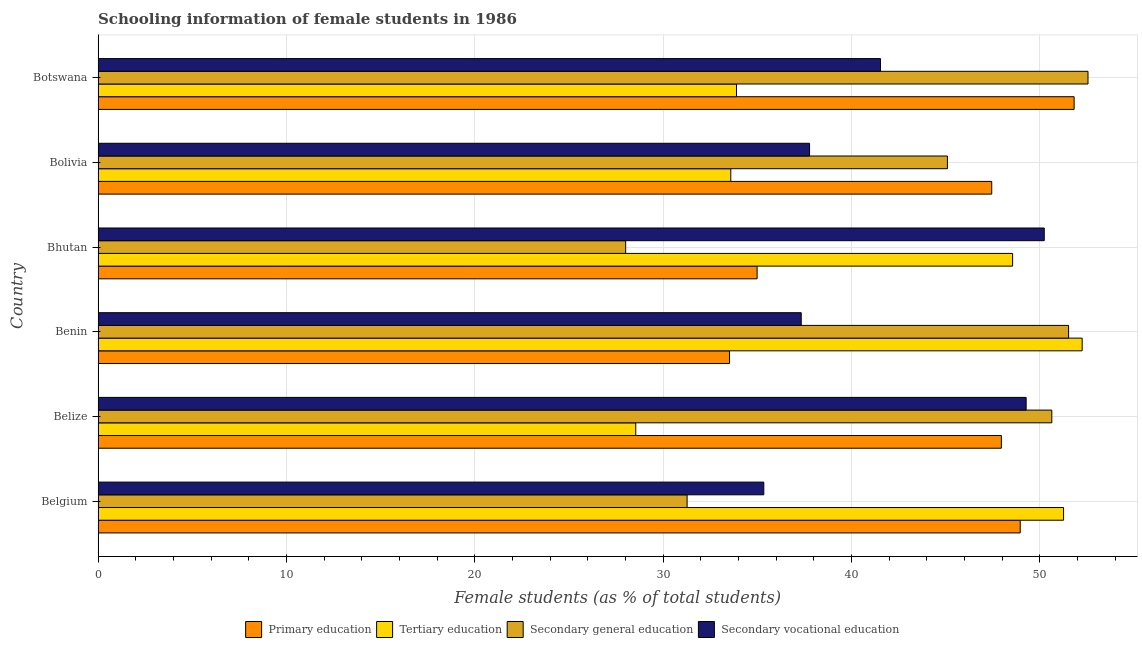How many bars are there on the 6th tick from the bottom?
Make the answer very short. 4. What is the label of the 3rd group of bars from the top?
Give a very brief answer. Bhutan. What is the percentage of female students in secondary education in Bolivia?
Give a very brief answer. 45.09. Across all countries, what is the maximum percentage of female students in tertiary education?
Your response must be concise. 52.24. Across all countries, what is the minimum percentage of female students in secondary education?
Ensure brevity in your answer.  28.01. In which country was the percentage of female students in primary education maximum?
Your response must be concise. Botswana. In which country was the percentage of female students in secondary education minimum?
Ensure brevity in your answer.  Bhutan. What is the total percentage of female students in secondary education in the graph?
Provide a short and direct response. 259.06. What is the difference between the percentage of female students in secondary education in Bhutan and that in Botswana?
Give a very brief answer. -24.54. What is the difference between the percentage of female students in tertiary education in Benin and the percentage of female students in secondary education in Bhutan?
Provide a short and direct response. 24.23. What is the average percentage of female students in secondary vocational education per country?
Offer a terse response. 41.91. What is the difference between the percentage of female students in primary education and percentage of female students in tertiary education in Bolivia?
Make the answer very short. 13.85. In how many countries, is the percentage of female students in primary education greater than 34 %?
Your answer should be very brief. 5. What is the ratio of the percentage of female students in tertiary education in Bolivia to that in Botswana?
Offer a terse response. 0.99. Is the difference between the percentage of female students in secondary education in Belize and Bolivia greater than the difference between the percentage of female students in secondary vocational education in Belize and Bolivia?
Your answer should be very brief. No. What is the difference between the highest and the second highest percentage of female students in primary education?
Your answer should be very brief. 2.86. What is the difference between the highest and the lowest percentage of female students in secondary education?
Provide a short and direct response. 24.54. Is it the case that in every country, the sum of the percentage of female students in tertiary education and percentage of female students in secondary vocational education is greater than the sum of percentage of female students in primary education and percentage of female students in secondary education?
Keep it short and to the point. No. What does the 3rd bar from the top in Bhutan represents?
Offer a terse response. Tertiary education. Is it the case that in every country, the sum of the percentage of female students in primary education and percentage of female students in tertiary education is greater than the percentage of female students in secondary education?
Ensure brevity in your answer.  Yes. How many bars are there?
Keep it short and to the point. 24. Are all the bars in the graph horizontal?
Offer a very short reply. Yes. What is the difference between two consecutive major ticks on the X-axis?
Offer a very short reply. 10. Does the graph contain any zero values?
Make the answer very short. No. Where does the legend appear in the graph?
Give a very brief answer. Bottom center. How many legend labels are there?
Your response must be concise. 4. How are the legend labels stacked?
Give a very brief answer. Horizontal. What is the title of the graph?
Make the answer very short. Schooling information of female students in 1986. What is the label or title of the X-axis?
Keep it short and to the point. Female students (as % of total students). What is the Female students (as % of total students) in Primary education in Belgium?
Provide a succinct answer. 48.95. What is the Female students (as % of total students) in Tertiary education in Belgium?
Make the answer very short. 51.25. What is the Female students (as % of total students) in Secondary general education in Belgium?
Your answer should be compact. 31.27. What is the Female students (as % of total students) of Secondary vocational education in Belgium?
Make the answer very short. 35.34. What is the Female students (as % of total students) of Primary education in Belize?
Your answer should be very brief. 47.95. What is the Female students (as % of total students) of Tertiary education in Belize?
Keep it short and to the point. 28.54. What is the Female students (as % of total students) of Secondary general education in Belize?
Your response must be concise. 50.63. What is the Female students (as % of total students) in Secondary vocational education in Belize?
Your answer should be compact. 49.27. What is the Female students (as % of total students) of Primary education in Benin?
Provide a short and direct response. 33.52. What is the Female students (as % of total students) of Tertiary education in Benin?
Give a very brief answer. 52.24. What is the Female students (as % of total students) of Secondary general education in Benin?
Your response must be concise. 51.52. What is the Female students (as % of total students) in Secondary vocational education in Benin?
Provide a short and direct response. 37.33. What is the Female students (as % of total students) in Primary education in Bhutan?
Ensure brevity in your answer.  34.98. What is the Female students (as % of total students) of Tertiary education in Bhutan?
Your answer should be compact. 48.55. What is the Female students (as % of total students) of Secondary general education in Bhutan?
Ensure brevity in your answer.  28.01. What is the Female students (as % of total students) in Secondary vocational education in Bhutan?
Keep it short and to the point. 50.23. What is the Female students (as % of total students) in Primary education in Bolivia?
Ensure brevity in your answer.  47.44. What is the Female students (as % of total students) in Tertiary education in Bolivia?
Provide a succinct answer. 33.59. What is the Female students (as % of total students) of Secondary general education in Bolivia?
Your answer should be very brief. 45.09. What is the Female students (as % of total students) of Secondary vocational education in Bolivia?
Your answer should be very brief. 37.77. What is the Female students (as % of total students) of Primary education in Botswana?
Your answer should be compact. 51.81. What is the Female students (as % of total students) of Tertiary education in Botswana?
Offer a very short reply. 33.89. What is the Female students (as % of total students) of Secondary general education in Botswana?
Provide a short and direct response. 52.55. What is the Female students (as % of total students) of Secondary vocational education in Botswana?
Make the answer very short. 41.53. Across all countries, what is the maximum Female students (as % of total students) in Primary education?
Your response must be concise. 51.81. Across all countries, what is the maximum Female students (as % of total students) in Tertiary education?
Provide a succinct answer. 52.24. Across all countries, what is the maximum Female students (as % of total students) of Secondary general education?
Your response must be concise. 52.55. Across all countries, what is the maximum Female students (as % of total students) in Secondary vocational education?
Ensure brevity in your answer.  50.23. Across all countries, what is the minimum Female students (as % of total students) in Primary education?
Your response must be concise. 33.52. Across all countries, what is the minimum Female students (as % of total students) of Tertiary education?
Provide a succinct answer. 28.54. Across all countries, what is the minimum Female students (as % of total students) in Secondary general education?
Keep it short and to the point. 28.01. Across all countries, what is the minimum Female students (as % of total students) of Secondary vocational education?
Keep it short and to the point. 35.34. What is the total Female students (as % of total students) of Primary education in the graph?
Offer a very short reply. 264.66. What is the total Female students (as % of total students) of Tertiary education in the graph?
Give a very brief answer. 248.06. What is the total Female students (as % of total students) of Secondary general education in the graph?
Provide a succinct answer. 259.06. What is the total Female students (as % of total students) in Secondary vocational education in the graph?
Offer a terse response. 251.46. What is the difference between the Female students (as % of total students) of Tertiary education in Belgium and that in Belize?
Your answer should be very brief. 22.71. What is the difference between the Female students (as % of total students) in Secondary general education in Belgium and that in Belize?
Offer a very short reply. -19.36. What is the difference between the Female students (as % of total students) of Secondary vocational education in Belgium and that in Belize?
Provide a short and direct response. -13.93. What is the difference between the Female students (as % of total students) in Primary education in Belgium and that in Benin?
Your response must be concise. 15.43. What is the difference between the Female students (as % of total students) of Tertiary education in Belgium and that in Benin?
Offer a very short reply. -0.99. What is the difference between the Female students (as % of total students) in Secondary general education in Belgium and that in Benin?
Offer a terse response. -20.25. What is the difference between the Female students (as % of total students) of Secondary vocational education in Belgium and that in Benin?
Offer a very short reply. -1.99. What is the difference between the Female students (as % of total students) in Primary education in Belgium and that in Bhutan?
Ensure brevity in your answer.  13.97. What is the difference between the Female students (as % of total students) of Tertiary education in Belgium and that in Bhutan?
Ensure brevity in your answer.  2.7. What is the difference between the Female students (as % of total students) in Secondary general education in Belgium and that in Bhutan?
Offer a terse response. 3.26. What is the difference between the Female students (as % of total students) in Secondary vocational education in Belgium and that in Bhutan?
Ensure brevity in your answer.  -14.89. What is the difference between the Female students (as % of total students) of Primary education in Belgium and that in Bolivia?
Offer a terse response. 1.51. What is the difference between the Female students (as % of total students) in Tertiary education in Belgium and that in Bolivia?
Ensure brevity in your answer.  17.67. What is the difference between the Female students (as % of total students) of Secondary general education in Belgium and that in Bolivia?
Keep it short and to the point. -13.82. What is the difference between the Female students (as % of total students) of Secondary vocational education in Belgium and that in Bolivia?
Your response must be concise. -2.43. What is the difference between the Female students (as % of total students) in Primary education in Belgium and that in Botswana?
Offer a very short reply. -2.86. What is the difference between the Female students (as % of total students) in Tertiary education in Belgium and that in Botswana?
Offer a very short reply. 17.36. What is the difference between the Female students (as % of total students) in Secondary general education in Belgium and that in Botswana?
Offer a very short reply. -21.28. What is the difference between the Female students (as % of total students) of Secondary vocational education in Belgium and that in Botswana?
Provide a succinct answer. -6.19. What is the difference between the Female students (as % of total students) in Primary education in Belize and that in Benin?
Your answer should be very brief. 14.43. What is the difference between the Female students (as % of total students) of Tertiary education in Belize and that in Benin?
Keep it short and to the point. -23.7. What is the difference between the Female students (as % of total students) in Secondary general education in Belize and that in Benin?
Offer a terse response. -0.89. What is the difference between the Female students (as % of total students) in Secondary vocational education in Belize and that in Benin?
Give a very brief answer. 11.94. What is the difference between the Female students (as % of total students) in Primary education in Belize and that in Bhutan?
Ensure brevity in your answer.  12.97. What is the difference between the Female students (as % of total students) of Tertiary education in Belize and that in Bhutan?
Your response must be concise. -20.01. What is the difference between the Female students (as % of total students) of Secondary general education in Belize and that in Bhutan?
Ensure brevity in your answer.  22.62. What is the difference between the Female students (as % of total students) in Secondary vocational education in Belize and that in Bhutan?
Your answer should be very brief. -0.96. What is the difference between the Female students (as % of total students) in Primary education in Belize and that in Bolivia?
Make the answer very short. 0.51. What is the difference between the Female students (as % of total students) in Tertiary education in Belize and that in Bolivia?
Your response must be concise. -5.04. What is the difference between the Female students (as % of total students) of Secondary general education in Belize and that in Bolivia?
Make the answer very short. 5.54. What is the difference between the Female students (as % of total students) in Secondary vocational education in Belize and that in Bolivia?
Your answer should be compact. 11.5. What is the difference between the Female students (as % of total students) of Primary education in Belize and that in Botswana?
Offer a terse response. -3.86. What is the difference between the Female students (as % of total students) of Tertiary education in Belize and that in Botswana?
Provide a succinct answer. -5.35. What is the difference between the Female students (as % of total students) of Secondary general education in Belize and that in Botswana?
Make the answer very short. -1.92. What is the difference between the Female students (as % of total students) of Secondary vocational education in Belize and that in Botswana?
Give a very brief answer. 7.73. What is the difference between the Female students (as % of total students) of Primary education in Benin and that in Bhutan?
Ensure brevity in your answer.  -1.46. What is the difference between the Female students (as % of total students) in Tertiary education in Benin and that in Bhutan?
Your answer should be compact. 3.69. What is the difference between the Female students (as % of total students) of Secondary general education in Benin and that in Bhutan?
Your response must be concise. 23.51. What is the difference between the Female students (as % of total students) in Secondary vocational education in Benin and that in Bhutan?
Ensure brevity in your answer.  -12.9. What is the difference between the Female students (as % of total students) of Primary education in Benin and that in Bolivia?
Your response must be concise. -13.92. What is the difference between the Female students (as % of total students) in Tertiary education in Benin and that in Bolivia?
Offer a very short reply. 18.65. What is the difference between the Female students (as % of total students) of Secondary general education in Benin and that in Bolivia?
Keep it short and to the point. 6.43. What is the difference between the Female students (as % of total students) of Secondary vocational education in Benin and that in Bolivia?
Ensure brevity in your answer.  -0.44. What is the difference between the Female students (as % of total students) of Primary education in Benin and that in Botswana?
Provide a short and direct response. -18.29. What is the difference between the Female students (as % of total students) of Tertiary education in Benin and that in Botswana?
Offer a terse response. 18.35. What is the difference between the Female students (as % of total students) of Secondary general education in Benin and that in Botswana?
Keep it short and to the point. -1.03. What is the difference between the Female students (as % of total students) in Secondary vocational education in Benin and that in Botswana?
Ensure brevity in your answer.  -4.21. What is the difference between the Female students (as % of total students) in Primary education in Bhutan and that in Bolivia?
Your answer should be compact. -12.46. What is the difference between the Female students (as % of total students) in Tertiary education in Bhutan and that in Bolivia?
Your answer should be compact. 14.96. What is the difference between the Female students (as % of total students) in Secondary general education in Bhutan and that in Bolivia?
Your answer should be very brief. -17.08. What is the difference between the Female students (as % of total students) in Secondary vocational education in Bhutan and that in Bolivia?
Provide a succinct answer. 12.46. What is the difference between the Female students (as % of total students) of Primary education in Bhutan and that in Botswana?
Your answer should be very brief. -16.83. What is the difference between the Female students (as % of total students) in Tertiary education in Bhutan and that in Botswana?
Keep it short and to the point. 14.66. What is the difference between the Female students (as % of total students) in Secondary general education in Bhutan and that in Botswana?
Provide a succinct answer. -24.54. What is the difference between the Female students (as % of total students) of Secondary vocational education in Bhutan and that in Botswana?
Offer a very short reply. 8.69. What is the difference between the Female students (as % of total students) in Primary education in Bolivia and that in Botswana?
Your response must be concise. -4.37. What is the difference between the Female students (as % of total students) of Tertiary education in Bolivia and that in Botswana?
Ensure brevity in your answer.  -0.3. What is the difference between the Female students (as % of total students) in Secondary general education in Bolivia and that in Botswana?
Your answer should be very brief. -7.46. What is the difference between the Female students (as % of total students) in Secondary vocational education in Bolivia and that in Botswana?
Your response must be concise. -3.76. What is the difference between the Female students (as % of total students) of Primary education in Belgium and the Female students (as % of total students) of Tertiary education in Belize?
Make the answer very short. 20.41. What is the difference between the Female students (as % of total students) of Primary education in Belgium and the Female students (as % of total students) of Secondary general education in Belize?
Provide a succinct answer. -1.68. What is the difference between the Female students (as % of total students) in Primary education in Belgium and the Female students (as % of total students) in Secondary vocational education in Belize?
Offer a very short reply. -0.31. What is the difference between the Female students (as % of total students) of Tertiary education in Belgium and the Female students (as % of total students) of Secondary general education in Belize?
Give a very brief answer. 0.62. What is the difference between the Female students (as % of total students) in Tertiary education in Belgium and the Female students (as % of total students) in Secondary vocational education in Belize?
Give a very brief answer. 1.99. What is the difference between the Female students (as % of total students) in Secondary general education in Belgium and the Female students (as % of total students) in Secondary vocational education in Belize?
Offer a very short reply. -18. What is the difference between the Female students (as % of total students) of Primary education in Belgium and the Female students (as % of total students) of Tertiary education in Benin?
Provide a short and direct response. -3.29. What is the difference between the Female students (as % of total students) in Primary education in Belgium and the Female students (as % of total students) in Secondary general education in Benin?
Ensure brevity in your answer.  -2.57. What is the difference between the Female students (as % of total students) of Primary education in Belgium and the Female students (as % of total students) of Secondary vocational education in Benin?
Keep it short and to the point. 11.62. What is the difference between the Female students (as % of total students) of Tertiary education in Belgium and the Female students (as % of total students) of Secondary general education in Benin?
Ensure brevity in your answer.  -0.27. What is the difference between the Female students (as % of total students) in Tertiary education in Belgium and the Female students (as % of total students) in Secondary vocational education in Benin?
Keep it short and to the point. 13.93. What is the difference between the Female students (as % of total students) of Secondary general education in Belgium and the Female students (as % of total students) of Secondary vocational education in Benin?
Your response must be concise. -6.06. What is the difference between the Female students (as % of total students) of Primary education in Belgium and the Female students (as % of total students) of Tertiary education in Bhutan?
Give a very brief answer. 0.4. What is the difference between the Female students (as % of total students) of Primary education in Belgium and the Female students (as % of total students) of Secondary general education in Bhutan?
Your answer should be compact. 20.94. What is the difference between the Female students (as % of total students) of Primary education in Belgium and the Female students (as % of total students) of Secondary vocational education in Bhutan?
Provide a short and direct response. -1.28. What is the difference between the Female students (as % of total students) of Tertiary education in Belgium and the Female students (as % of total students) of Secondary general education in Bhutan?
Offer a very short reply. 23.25. What is the difference between the Female students (as % of total students) of Tertiary education in Belgium and the Female students (as % of total students) of Secondary vocational education in Bhutan?
Offer a terse response. 1.03. What is the difference between the Female students (as % of total students) of Secondary general education in Belgium and the Female students (as % of total students) of Secondary vocational education in Bhutan?
Offer a very short reply. -18.96. What is the difference between the Female students (as % of total students) of Primary education in Belgium and the Female students (as % of total students) of Tertiary education in Bolivia?
Make the answer very short. 15.36. What is the difference between the Female students (as % of total students) of Primary education in Belgium and the Female students (as % of total students) of Secondary general education in Bolivia?
Ensure brevity in your answer.  3.86. What is the difference between the Female students (as % of total students) in Primary education in Belgium and the Female students (as % of total students) in Secondary vocational education in Bolivia?
Provide a short and direct response. 11.18. What is the difference between the Female students (as % of total students) in Tertiary education in Belgium and the Female students (as % of total students) in Secondary general education in Bolivia?
Provide a succinct answer. 6.17. What is the difference between the Female students (as % of total students) in Tertiary education in Belgium and the Female students (as % of total students) in Secondary vocational education in Bolivia?
Keep it short and to the point. 13.48. What is the difference between the Female students (as % of total students) in Secondary general education in Belgium and the Female students (as % of total students) in Secondary vocational education in Bolivia?
Give a very brief answer. -6.5. What is the difference between the Female students (as % of total students) of Primary education in Belgium and the Female students (as % of total students) of Tertiary education in Botswana?
Ensure brevity in your answer.  15.06. What is the difference between the Female students (as % of total students) of Primary education in Belgium and the Female students (as % of total students) of Secondary general education in Botswana?
Your answer should be compact. -3.6. What is the difference between the Female students (as % of total students) of Primary education in Belgium and the Female students (as % of total students) of Secondary vocational education in Botswana?
Provide a short and direct response. 7.42. What is the difference between the Female students (as % of total students) in Tertiary education in Belgium and the Female students (as % of total students) in Secondary general education in Botswana?
Keep it short and to the point. -1.3. What is the difference between the Female students (as % of total students) in Tertiary education in Belgium and the Female students (as % of total students) in Secondary vocational education in Botswana?
Provide a succinct answer. 9.72. What is the difference between the Female students (as % of total students) in Secondary general education in Belgium and the Female students (as % of total students) in Secondary vocational education in Botswana?
Offer a very short reply. -10.26. What is the difference between the Female students (as % of total students) of Primary education in Belize and the Female students (as % of total students) of Tertiary education in Benin?
Keep it short and to the point. -4.29. What is the difference between the Female students (as % of total students) of Primary education in Belize and the Female students (as % of total students) of Secondary general education in Benin?
Your answer should be very brief. -3.57. What is the difference between the Female students (as % of total students) in Primary education in Belize and the Female students (as % of total students) in Secondary vocational education in Benin?
Keep it short and to the point. 10.62. What is the difference between the Female students (as % of total students) of Tertiary education in Belize and the Female students (as % of total students) of Secondary general education in Benin?
Give a very brief answer. -22.98. What is the difference between the Female students (as % of total students) of Tertiary education in Belize and the Female students (as % of total students) of Secondary vocational education in Benin?
Offer a terse response. -8.78. What is the difference between the Female students (as % of total students) of Secondary general education in Belize and the Female students (as % of total students) of Secondary vocational education in Benin?
Your answer should be very brief. 13.3. What is the difference between the Female students (as % of total students) in Primary education in Belize and the Female students (as % of total students) in Tertiary education in Bhutan?
Your answer should be compact. -0.6. What is the difference between the Female students (as % of total students) of Primary education in Belize and the Female students (as % of total students) of Secondary general education in Bhutan?
Your answer should be compact. 19.94. What is the difference between the Female students (as % of total students) of Primary education in Belize and the Female students (as % of total students) of Secondary vocational education in Bhutan?
Provide a succinct answer. -2.28. What is the difference between the Female students (as % of total students) of Tertiary education in Belize and the Female students (as % of total students) of Secondary general education in Bhutan?
Your answer should be compact. 0.54. What is the difference between the Female students (as % of total students) of Tertiary education in Belize and the Female students (as % of total students) of Secondary vocational education in Bhutan?
Ensure brevity in your answer.  -21.68. What is the difference between the Female students (as % of total students) of Secondary general education in Belize and the Female students (as % of total students) of Secondary vocational education in Bhutan?
Your answer should be compact. 0.4. What is the difference between the Female students (as % of total students) of Primary education in Belize and the Female students (as % of total students) of Tertiary education in Bolivia?
Your response must be concise. 14.36. What is the difference between the Female students (as % of total students) of Primary education in Belize and the Female students (as % of total students) of Secondary general education in Bolivia?
Provide a succinct answer. 2.86. What is the difference between the Female students (as % of total students) in Primary education in Belize and the Female students (as % of total students) in Secondary vocational education in Bolivia?
Offer a terse response. 10.18. What is the difference between the Female students (as % of total students) of Tertiary education in Belize and the Female students (as % of total students) of Secondary general education in Bolivia?
Your answer should be compact. -16.54. What is the difference between the Female students (as % of total students) in Tertiary education in Belize and the Female students (as % of total students) in Secondary vocational education in Bolivia?
Make the answer very short. -9.23. What is the difference between the Female students (as % of total students) of Secondary general education in Belize and the Female students (as % of total students) of Secondary vocational education in Bolivia?
Your answer should be compact. 12.86. What is the difference between the Female students (as % of total students) in Primary education in Belize and the Female students (as % of total students) in Tertiary education in Botswana?
Your response must be concise. 14.06. What is the difference between the Female students (as % of total students) of Primary education in Belize and the Female students (as % of total students) of Secondary general education in Botswana?
Make the answer very short. -4.6. What is the difference between the Female students (as % of total students) in Primary education in Belize and the Female students (as % of total students) in Secondary vocational education in Botswana?
Ensure brevity in your answer.  6.42. What is the difference between the Female students (as % of total students) of Tertiary education in Belize and the Female students (as % of total students) of Secondary general education in Botswana?
Make the answer very short. -24.01. What is the difference between the Female students (as % of total students) of Tertiary education in Belize and the Female students (as % of total students) of Secondary vocational education in Botswana?
Your answer should be very brief. -12.99. What is the difference between the Female students (as % of total students) in Secondary general education in Belize and the Female students (as % of total students) in Secondary vocational education in Botswana?
Your answer should be compact. 9.1. What is the difference between the Female students (as % of total students) of Primary education in Benin and the Female students (as % of total students) of Tertiary education in Bhutan?
Ensure brevity in your answer.  -15.03. What is the difference between the Female students (as % of total students) of Primary education in Benin and the Female students (as % of total students) of Secondary general education in Bhutan?
Your answer should be very brief. 5.51. What is the difference between the Female students (as % of total students) in Primary education in Benin and the Female students (as % of total students) in Secondary vocational education in Bhutan?
Provide a succinct answer. -16.71. What is the difference between the Female students (as % of total students) in Tertiary education in Benin and the Female students (as % of total students) in Secondary general education in Bhutan?
Provide a short and direct response. 24.23. What is the difference between the Female students (as % of total students) of Tertiary education in Benin and the Female students (as % of total students) of Secondary vocational education in Bhutan?
Offer a very short reply. 2.01. What is the difference between the Female students (as % of total students) of Secondary general education in Benin and the Female students (as % of total students) of Secondary vocational education in Bhutan?
Your answer should be very brief. 1.29. What is the difference between the Female students (as % of total students) in Primary education in Benin and the Female students (as % of total students) in Tertiary education in Bolivia?
Make the answer very short. -0.07. What is the difference between the Female students (as % of total students) in Primary education in Benin and the Female students (as % of total students) in Secondary general education in Bolivia?
Your answer should be compact. -11.57. What is the difference between the Female students (as % of total students) of Primary education in Benin and the Female students (as % of total students) of Secondary vocational education in Bolivia?
Offer a terse response. -4.25. What is the difference between the Female students (as % of total students) of Tertiary education in Benin and the Female students (as % of total students) of Secondary general education in Bolivia?
Your answer should be compact. 7.15. What is the difference between the Female students (as % of total students) of Tertiary education in Benin and the Female students (as % of total students) of Secondary vocational education in Bolivia?
Offer a very short reply. 14.47. What is the difference between the Female students (as % of total students) in Secondary general education in Benin and the Female students (as % of total students) in Secondary vocational education in Bolivia?
Ensure brevity in your answer.  13.75. What is the difference between the Female students (as % of total students) of Primary education in Benin and the Female students (as % of total students) of Tertiary education in Botswana?
Ensure brevity in your answer.  -0.37. What is the difference between the Female students (as % of total students) in Primary education in Benin and the Female students (as % of total students) in Secondary general education in Botswana?
Give a very brief answer. -19.03. What is the difference between the Female students (as % of total students) in Primary education in Benin and the Female students (as % of total students) in Secondary vocational education in Botswana?
Make the answer very short. -8.01. What is the difference between the Female students (as % of total students) in Tertiary education in Benin and the Female students (as % of total students) in Secondary general education in Botswana?
Provide a succinct answer. -0.31. What is the difference between the Female students (as % of total students) of Tertiary education in Benin and the Female students (as % of total students) of Secondary vocational education in Botswana?
Keep it short and to the point. 10.71. What is the difference between the Female students (as % of total students) of Secondary general education in Benin and the Female students (as % of total students) of Secondary vocational education in Botswana?
Your answer should be compact. 9.99. What is the difference between the Female students (as % of total students) of Primary education in Bhutan and the Female students (as % of total students) of Tertiary education in Bolivia?
Your response must be concise. 1.4. What is the difference between the Female students (as % of total students) of Primary education in Bhutan and the Female students (as % of total students) of Secondary general education in Bolivia?
Provide a succinct answer. -10.1. What is the difference between the Female students (as % of total students) in Primary education in Bhutan and the Female students (as % of total students) in Secondary vocational education in Bolivia?
Give a very brief answer. -2.79. What is the difference between the Female students (as % of total students) of Tertiary education in Bhutan and the Female students (as % of total students) of Secondary general education in Bolivia?
Offer a terse response. 3.46. What is the difference between the Female students (as % of total students) of Tertiary education in Bhutan and the Female students (as % of total students) of Secondary vocational education in Bolivia?
Give a very brief answer. 10.78. What is the difference between the Female students (as % of total students) in Secondary general education in Bhutan and the Female students (as % of total students) in Secondary vocational education in Bolivia?
Your answer should be compact. -9.76. What is the difference between the Female students (as % of total students) of Primary education in Bhutan and the Female students (as % of total students) of Tertiary education in Botswana?
Your answer should be very brief. 1.09. What is the difference between the Female students (as % of total students) in Primary education in Bhutan and the Female students (as % of total students) in Secondary general education in Botswana?
Ensure brevity in your answer.  -17.57. What is the difference between the Female students (as % of total students) in Primary education in Bhutan and the Female students (as % of total students) in Secondary vocational education in Botswana?
Offer a very short reply. -6.55. What is the difference between the Female students (as % of total students) of Tertiary education in Bhutan and the Female students (as % of total students) of Secondary general education in Botswana?
Your answer should be compact. -4. What is the difference between the Female students (as % of total students) in Tertiary education in Bhutan and the Female students (as % of total students) in Secondary vocational education in Botswana?
Your answer should be compact. 7.01. What is the difference between the Female students (as % of total students) of Secondary general education in Bhutan and the Female students (as % of total students) of Secondary vocational education in Botswana?
Offer a very short reply. -13.53. What is the difference between the Female students (as % of total students) in Primary education in Bolivia and the Female students (as % of total students) in Tertiary education in Botswana?
Offer a very short reply. 13.55. What is the difference between the Female students (as % of total students) in Primary education in Bolivia and the Female students (as % of total students) in Secondary general education in Botswana?
Your answer should be compact. -5.11. What is the difference between the Female students (as % of total students) in Primary education in Bolivia and the Female students (as % of total students) in Secondary vocational education in Botswana?
Make the answer very short. 5.91. What is the difference between the Female students (as % of total students) of Tertiary education in Bolivia and the Female students (as % of total students) of Secondary general education in Botswana?
Make the answer very short. -18.96. What is the difference between the Female students (as % of total students) of Tertiary education in Bolivia and the Female students (as % of total students) of Secondary vocational education in Botswana?
Your response must be concise. -7.95. What is the difference between the Female students (as % of total students) in Secondary general education in Bolivia and the Female students (as % of total students) in Secondary vocational education in Botswana?
Keep it short and to the point. 3.55. What is the average Female students (as % of total students) of Primary education per country?
Ensure brevity in your answer.  44.11. What is the average Female students (as % of total students) in Tertiary education per country?
Offer a terse response. 41.34. What is the average Female students (as % of total students) in Secondary general education per country?
Give a very brief answer. 43.18. What is the average Female students (as % of total students) of Secondary vocational education per country?
Provide a succinct answer. 41.91. What is the difference between the Female students (as % of total students) of Primary education and Female students (as % of total students) of Tertiary education in Belgium?
Provide a succinct answer. -2.3. What is the difference between the Female students (as % of total students) in Primary education and Female students (as % of total students) in Secondary general education in Belgium?
Give a very brief answer. 17.68. What is the difference between the Female students (as % of total students) of Primary education and Female students (as % of total students) of Secondary vocational education in Belgium?
Your answer should be very brief. 13.61. What is the difference between the Female students (as % of total students) of Tertiary education and Female students (as % of total students) of Secondary general education in Belgium?
Your answer should be compact. 19.98. What is the difference between the Female students (as % of total students) of Tertiary education and Female students (as % of total students) of Secondary vocational education in Belgium?
Ensure brevity in your answer.  15.91. What is the difference between the Female students (as % of total students) of Secondary general education and Female students (as % of total students) of Secondary vocational education in Belgium?
Your answer should be very brief. -4.07. What is the difference between the Female students (as % of total students) in Primary education and Female students (as % of total students) in Tertiary education in Belize?
Ensure brevity in your answer.  19.41. What is the difference between the Female students (as % of total students) of Primary education and Female students (as % of total students) of Secondary general education in Belize?
Offer a terse response. -2.68. What is the difference between the Female students (as % of total students) in Primary education and Female students (as % of total students) in Secondary vocational education in Belize?
Your response must be concise. -1.32. What is the difference between the Female students (as % of total students) of Tertiary education and Female students (as % of total students) of Secondary general education in Belize?
Make the answer very short. -22.09. What is the difference between the Female students (as % of total students) of Tertiary education and Female students (as % of total students) of Secondary vocational education in Belize?
Your response must be concise. -20.72. What is the difference between the Female students (as % of total students) of Secondary general education and Female students (as % of total students) of Secondary vocational education in Belize?
Offer a terse response. 1.36. What is the difference between the Female students (as % of total students) in Primary education and Female students (as % of total students) in Tertiary education in Benin?
Provide a short and direct response. -18.72. What is the difference between the Female students (as % of total students) of Primary education and Female students (as % of total students) of Secondary general education in Benin?
Provide a succinct answer. -18. What is the difference between the Female students (as % of total students) in Primary education and Female students (as % of total students) in Secondary vocational education in Benin?
Your response must be concise. -3.81. What is the difference between the Female students (as % of total students) in Tertiary education and Female students (as % of total students) in Secondary general education in Benin?
Your response must be concise. 0.72. What is the difference between the Female students (as % of total students) in Tertiary education and Female students (as % of total students) in Secondary vocational education in Benin?
Ensure brevity in your answer.  14.91. What is the difference between the Female students (as % of total students) in Secondary general education and Female students (as % of total students) in Secondary vocational education in Benin?
Keep it short and to the point. 14.19. What is the difference between the Female students (as % of total students) of Primary education and Female students (as % of total students) of Tertiary education in Bhutan?
Your answer should be compact. -13.56. What is the difference between the Female students (as % of total students) in Primary education and Female students (as % of total students) in Secondary general education in Bhutan?
Your answer should be compact. 6.98. What is the difference between the Female students (as % of total students) in Primary education and Female students (as % of total students) in Secondary vocational education in Bhutan?
Your response must be concise. -15.24. What is the difference between the Female students (as % of total students) in Tertiary education and Female students (as % of total students) in Secondary general education in Bhutan?
Offer a very short reply. 20.54. What is the difference between the Female students (as % of total students) of Tertiary education and Female students (as % of total students) of Secondary vocational education in Bhutan?
Keep it short and to the point. -1.68. What is the difference between the Female students (as % of total students) of Secondary general education and Female students (as % of total students) of Secondary vocational education in Bhutan?
Your answer should be very brief. -22.22. What is the difference between the Female students (as % of total students) of Primary education and Female students (as % of total students) of Tertiary education in Bolivia?
Your answer should be very brief. 13.85. What is the difference between the Female students (as % of total students) of Primary education and Female students (as % of total students) of Secondary general education in Bolivia?
Your answer should be very brief. 2.35. What is the difference between the Female students (as % of total students) of Primary education and Female students (as % of total students) of Secondary vocational education in Bolivia?
Your answer should be compact. 9.67. What is the difference between the Female students (as % of total students) of Tertiary education and Female students (as % of total students) of Secondary general education in Bolivia?
Provide a succinct answer. -11.5. What is the difference between the Female students (as % of total students) in Tertiary education and Female students (as % of total students) in Secondary vocational education in Bolivia?
Ensure brevity in your answer.  -4.18. What is the difference between the Female students (as % of total students) in Secondary general education and Female students (as % of total students) in Secondary vocational education in Bolivia?
Your answer should be very brief. 7.32. What is the difference between the Female students (as % of total students) in Primary education and Female students (as % of total students) in Tertiary education in Botswana?
Your answer should be compact. 17.92. What is the difference between the Female students (as % of total students) of Primary education and Female students (as % of total students) of Secondary general education in Botswana?
Offer a terse response. -0.74. What is the difference between the Female students (as % of total students) of Primary education and Female students (as % of total students) of Secondary vocational education in Botswana?
Give a very brief answer. 10.28. What is the difference between the Female students (as % of total students) in Tertiary education and Female students (as % of total students) in Secondary general education in Botswana?
Your answer should be very brief. -18.66. What is the difference between the Female students (as % of total students) of Tertiary education and Female students (as % of total students) of Secondary vocational education in Botswana?
Provide a short and direct response. -7.64. What is the difference between the Female students (as % of total students) of Secondary general education and Female students (as % of total students) of Secondary vocational education in Botswana?
Provide a short and direct response. 11.02. What is the ratio of the Female students (as % of total students) in Primary education in Belgium to that in Belize?
Provide a short and direct response. 1.02. What is the ratio of the Female students (as % of total students) in Tertiary education in Belgium to that in Belize?
Offer a terse response. 1.8. What is the ratio of the Female students (as % of total students) in Secondary general education in Belgium to that in Belize?
Offer a very short reply. 0.62. What is the ratio of the Female students (as % of total students) in Secondary vocational education in Belgium to that in Belize?
Give a very brief answer. 0.72. What is the ratio of the Female students (as % of total students) in Primary education in Belgium to that in Benin?
Offer a very short reply. 1.46. What is the ratio of the Female students (as % of total students) in Tertiary education in Belgium to that in Benin?
Provide a succinct answer. 0.98. What is the ratio of the Female students (as % of total students) in Secondary general education in Belgium to that in Benin?
Ensure brevity in your answer.  0.61. What is the ratio of the Female students (as % of total students) in Secondary vocational education in Belgium to that in Benin?
Your answer should be compact. 0.95. What is the ratio of the Female students (as % of total students) in Primary education in Belgium to that in Bhutan?
Offer a very short reply. 1.4. What is the ratio of the Female students (as % of total students) of Tertiary education in Belgium to that in Bhutan?
Provide a short and direct response. 1.06. What is the ratio of the Female students (as % of total students) in Secondary general education in Belgium to that in Bhutan?
Provide a short and direct response. 1.12. What is the ratio of the Female students (as % of total students) in Secondary vocational education in Belgium to that in Bhutan?
Your answer should be compact. 0.7. What is the ratio of the Female students (as % of total students) of Primary education in Belgium to that in Bolivia?
Make the answer very short. 1.03. What is the ratio of the Female students (as % of total students) in Tertiary education in Belgium to that in Bolivia?
Offer a terse response. 1.53. What is the ratio of the Female students (as % of total students) of Secondary general education in Belgium to that in Bolivia?
Ensure brevity in your answer.  0.69. What is the ratio of the Female students (as % of total students) in Secondary vocational education in Belgium to that in Bolivia?
Give a very brief answer. 0.94. What is the ratio of the Female students (as % of total students) in Primary education in Belgium to that in Botswana?
Ensure brevity in your answer.  0.94. What is the ratio of the Female students (as % of total students) in Tertiary education in Belgium to that in Botswana?
Make the answer very short. 1.51. What is the ratio of the Female students (as % of total students) in Secondary general education in Belgium to that in Botswana?
Your response must be concise. 0.59. What is the ratio of the Female students (as % of total students) in Secondary vocational education in Belgium to that in Botswana?
Provide a succinct answer. 0.85. What is the ratio of the Female students (as % of total students) in Primary education in Belize to that in Benin?
Ensure brevity in your answer.  1.43. What is the ratio of the Female students (as % of total students) in Tertiary education in Belize to that in Benin?
Keep it short and to the point. 0.55. What is the ratio of the Female students (as % of total students) in Secondary general education in Belize to that in Benin?
Provide a short and direct response. 0.98. What is the ratio of the Female students (as % of total students) in Secondary vocational education in Belize to that in Benin?
Your answer should be very brief. 1.32. What is the ratio of the Female students (as % of total students) in Primary education in Belize to that in Bhutan?
Make the answer very short. 1.37. What is the ratio of the Female students (as % of total students) in Tertiary education in Belize to that in Bhutan?
Offer a terse response. 0.59. What is the ratio of the Female students (as % of total students) in Secondary general education in Belize to that in Bhutan?
Offer a terse response. 1.81. What is the ratio of the Female students (as % of total students) of Secondary vocational education in Belize to that in Bhutan?
Provide a succinct answer. 0.98. What is the ratio of the Female students (as % of total students) in Primary education in Belize to that in Bolivia?
Give a very brief answer. 1.01. What is the ratio of the Female students (as % of total students) in Tertiary education in Belize to that in Bolivia?
Your answer should be compact. 0.85. What is the ratio of the Female students (as % of total students) in Secondary general education in Belize to that in Bolivia?
Make the answer very short. 1.12. What is the ratio of the Female students (as % of total students) in Secondary vocational education in Belize to that in Bolivia?
Offer a very short reply. 1.3. What is the ratio of the Female students (as % of total students) of Primary education in Belize to that in Botswana?
Ensure brevity in your answer.  0.93. What is the ratio of the Female students (as % of total students) of Tertiary education in Belize to that in Botswana?
Keep it short and to the point. 0.84. What is the ratio of the Female students (as % of total students) in Secondary general education in Belize to that in Botswana?
Offer a terse response. 0.96. What is the ratio of the Female students (as % of total students) of Secondary vocational education in Belize to that in Botswana?
Your answer should be compact. 1.19. What is the ratio of the Female students (as % of total students) of Primary education in Benin to that in Bhutan?
Keep it short and to the point. 0.96. What is the ratio of the Female students (as % of total students) in Tertiary education in Benin to that in Bhutan?
Your answer should be compact. 1.08. What is the ratio of the Female students (as % of total students) of Secondary general education in Benin to that in Bhutan?
Offer a very short reply. 1.84. What is the ratio of the Female students (as % of total students) of Secondary vocational education in Benin to that in Bhutan?
Your answer should be very brief. 0.74. What is the ratio of the Female students (as % of total students) in Primary education in Benin to that in Bolivia?
Provide a short and direct response. 0.71. What is the ratio of the Female students (as % of total students) in Tertiary education in Benin to that in Bolivia?
Give a very brief answer. 1.56. What is the ratio of the Female students (as % of total students) in Secondary general education in Benin to that in Bolivia?
Ensure brevity in your answer.  1.14. What is the ratio of the Female students (as % of total students) in Secondary vocational education in Benin to that in Bolivia?
Keep it short and to the point. 0.99. What is the ratio of the Female students (as % of total students) of Primary education in Benin to that in Botswana?
Keep it short and to the point. 0.65. What is the ratio of the Female students (as % of total students) of Tertiary education in Benin to that in Botswana?
Give a very brief answer. 1.54. What is the ratio of the Female students (as % of total students) of Secondary general education in Benin to that in Botswana?
Your answer should be very brief. 0.98. What is the ratio of the Female students (as % of total students) of Secondary vocational education in Benin to that in Botswana?
Give a very brief answer. 0.9. What is the ratio of the Female students (as % of total students) in Primary education in Bhutan to that in Bolivia?
Provide a succinct answer. 0.74. What is the ratio of the Female students (as % of total students) of Tertiary education in Bhutan to that in Bolivia?
Make the answer very short. 1.45. What is the ratio of the Female students (as % of total students) in Secondary general education in Bhutan to that in Bolivia?
Offer a terse response. 0.62. What is the ratio of the Female students (as % of total students) of Secondary vocational education in Bhutan to that in Bolivia?
Keep it short and to the point. 1.33. What is the ratio of the Female students (as % of total students) in Primary education in Bhutan to that in Botswana?
Offer a terse response. 0.68. What is the ratio of the Female students (as % of total students) of Tertiary education in Bhutan to that in Botswana?
Your answer should be very brief. 1.43. What is the ratio of the Female students (as % of total students) of Secondary general education in Bhutan to that in Botswana?
Provide a succinct answer. 0.53. What is the ratio of the Female students (as % of total students) in Secondary vocational education in Bhutan to that in Botswana?
Make the answer very short. 1.21. What is the ratio of the Female students (as % of total students) of Primary education in Bolivia to that in Botswana?
Offer a terse response. 0.92. What is the ratio of the Female students (as % of total students) of Secondary general education in Bolivia to that in Botswana?
Offer a very short reply. 0.86. What is the ratio of the Female students (as % of total students) in Secondary vocational education in Bolivia to that in Botswana?
Your answer should be compact. 0.91. What is the difference between the highest and the second highest Female students (as % of total students) in Primary education?
Ensure brevity in your answer.  2.86. What is the difference between the highest and the second highest Female students (as % of total students) of Tertiary education?
Make the answer very short. 0.99. What is the difference between the highest and the second highest Female students (as % of total students) of Secondary general education?
Your answer should be compact. 1.03. What is the difference between the highest and the second highest Female students (as % of total students) in Secondary vocational education?
Your answer should be very brief. 0.96. What is the difference between the highest and the lowest Female students (as % of total students) of Primary education?
Your answer should be very brief. 18.29. What is the difference between the highest and the lowest Female students (as % of total students) of Tertiary education?
Offer a terse response. 23.7. What is the difference between the highest and the lowest Female students (as % of total students) of Secondary general education?
Offer a very short reply. 24.54. What is the difference between the highest and the lowest Female students (as % of total students) in Secondary vocational education?
Provide a succinct answer. 14.89. 